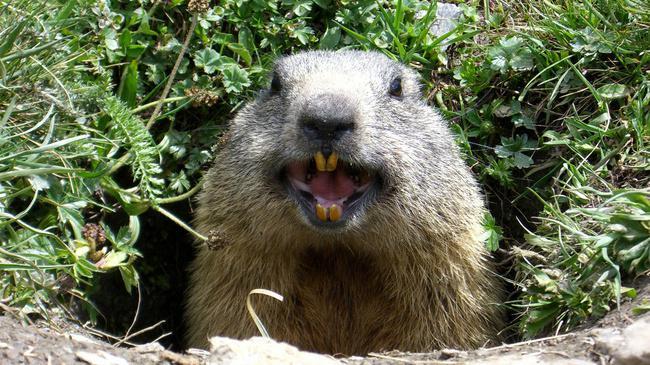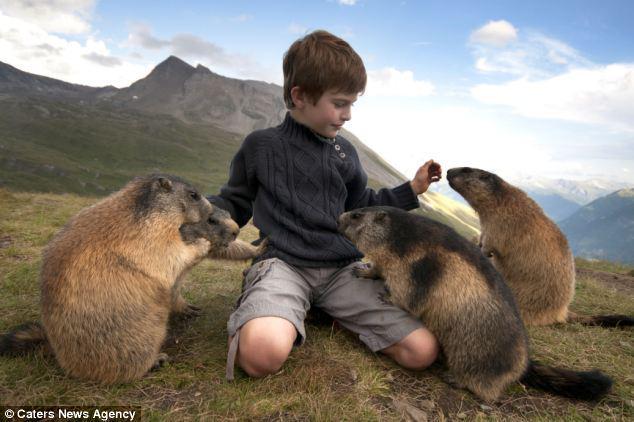The first image is the image on the left, the second image is the image on the right. Evaluate the accuracy of this statement regarding the images: "There are three marmots". Is it true? Answer yes or no. No. The first image is the image on the left, the second image is the image on the right. Analyze the images presented: Is the assertion "One image includes exactly twice as many marmots as the other image." valid? Answer yes or no. No. 